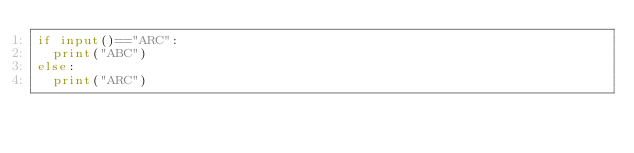<code> <loc_0><loc_0><loc_500><loc_500><_Python_>if input()=="ARC":
  print("ABC")
else:
  print("ARC")</code> 